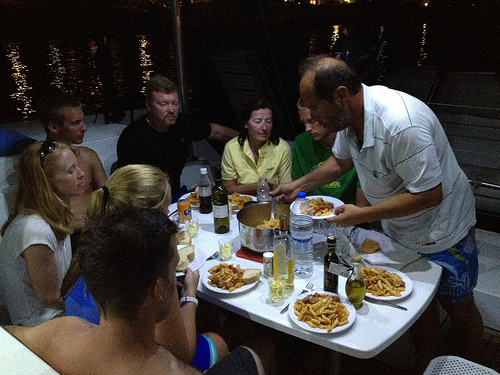Signify the interaction among people in the image. The individuals appear engaged in light-hearted conversation, evident from their relaxed postures and expressions, suggesting a friendly interaction possibly during a shared meal on a leisurely boat ride. 